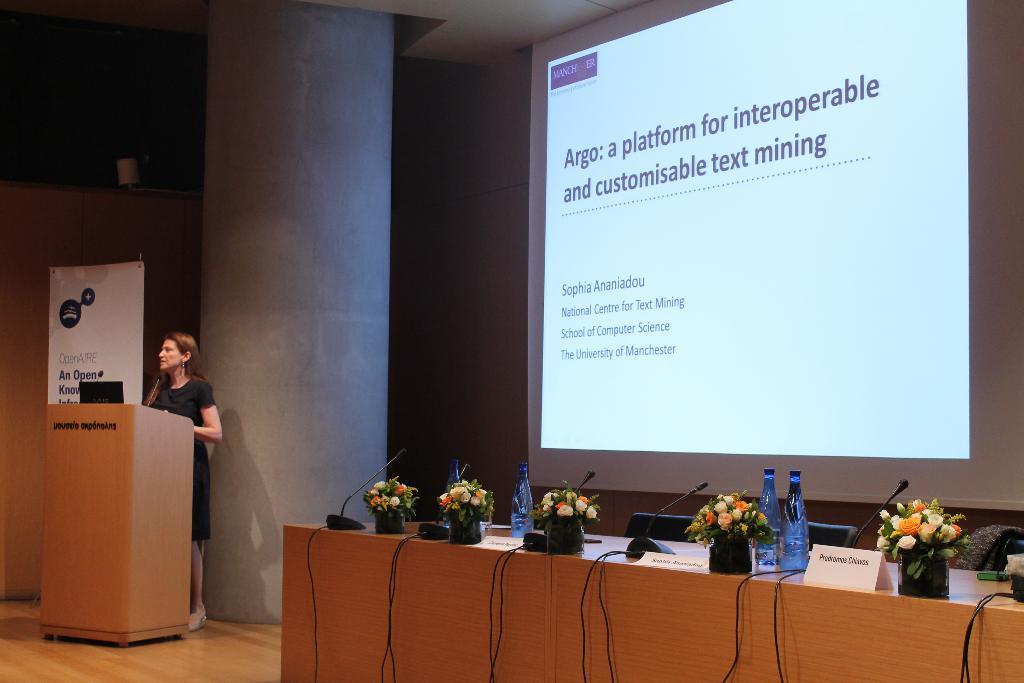Please provide a concise description of this image. This is an inside view. On the right side there is a screen on which I can see some text. At the bottom there is a table on which few flower pots, bottles, microphones are placed. Behind the table there are few empty chairs. On the left side there is a woman standing in front of the podium. At the back of her there is a pillar. In the background, I can see a white color banner which is attached to the wall. 